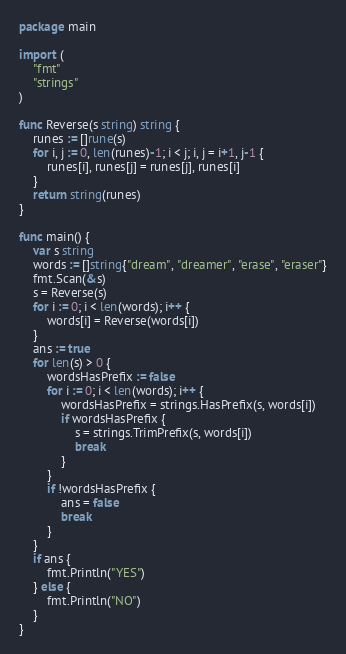<code> <loc_0><loc_0><loc_500><loc_500><_Go_>package main

import (
	"fmt"
	"strings"
)

func Reverse(s string) string {
    runes := []rune(s)
    for i, j := 0, len(runes)-1; i < j; i, j = i+1, j-1 {
        runes[i], runes[j] = runes[j], runes[i]
    }
    return string(runes)
}

func main() {
	var s string
	words := []string{"dream", "dreamer", "erase", "eraser"}
	fmt.Scan(&s)
	s = Reverse(s)
	for i := 0; i < len(words); i++ {
		words[i] = Reverse(words[i])
	}
	ans := true
	for len(s) > 0 {
		wordsHasPrefix := false
		for i := 0; i < len(words); i++ {
			wordsHasPrefix = strings.HasPrefix(s, words[i])
			if wordsHasPrefix {
				s = strings.TrimPrefix(s, words[i])
				break
			}
		}
		if !wordsHasPrefix {
			ans = false
			break 
		}
	}
	if ans {
		fmt.Println("YES")	
	} else {
		fmt.Println("NO")	
	}
}</code> 